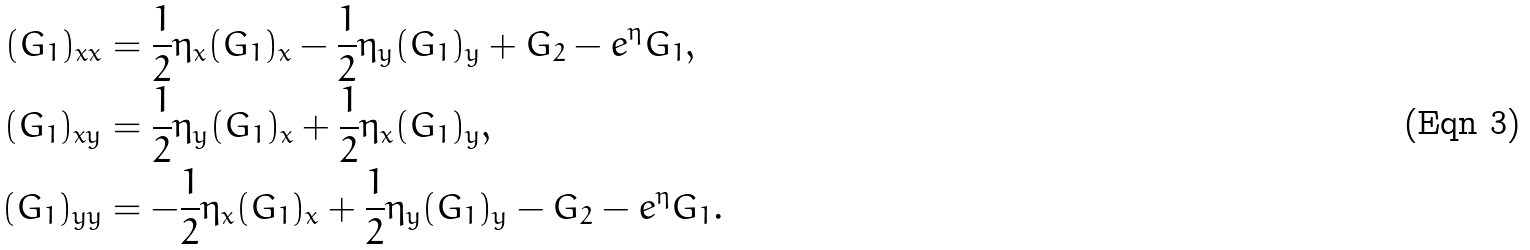<formula> <loc_0><loc_0><loc_500><loc_500>( G _ { 1 } ) _ { x x } & = \frac { 1 } { 2 } \eta _ { x } ( G _ { 1 } ) _ { x } - \frac { 1 } { 2 } \eta _ { y } ( G _ { 1 } ) _ { y } + G _ { 2 } - e ^ { \eta } G _ { 1 } , \\ ( G _ { 1 } ) _ { x y } & = \frac { 1 } { 2 } \eta _ { y } ( G _ { 1 } ) _ { x } + \frac { 1 } { 2 } \eta _ { x } ( G _ { 1 } ) _ { y } , \\ ( G _ { 1 } ) _ { y y } & = - \frac { 1 } { 2 } \eta _ { x } ( G _ { 1 } ) _ { x } + \frac { 1 } { 2 } \eta _ { y } ( G _ { 1 } ) _ { y } - G _ { 2 } - e ^ { \eta } G _ { 1 } .</formula> 